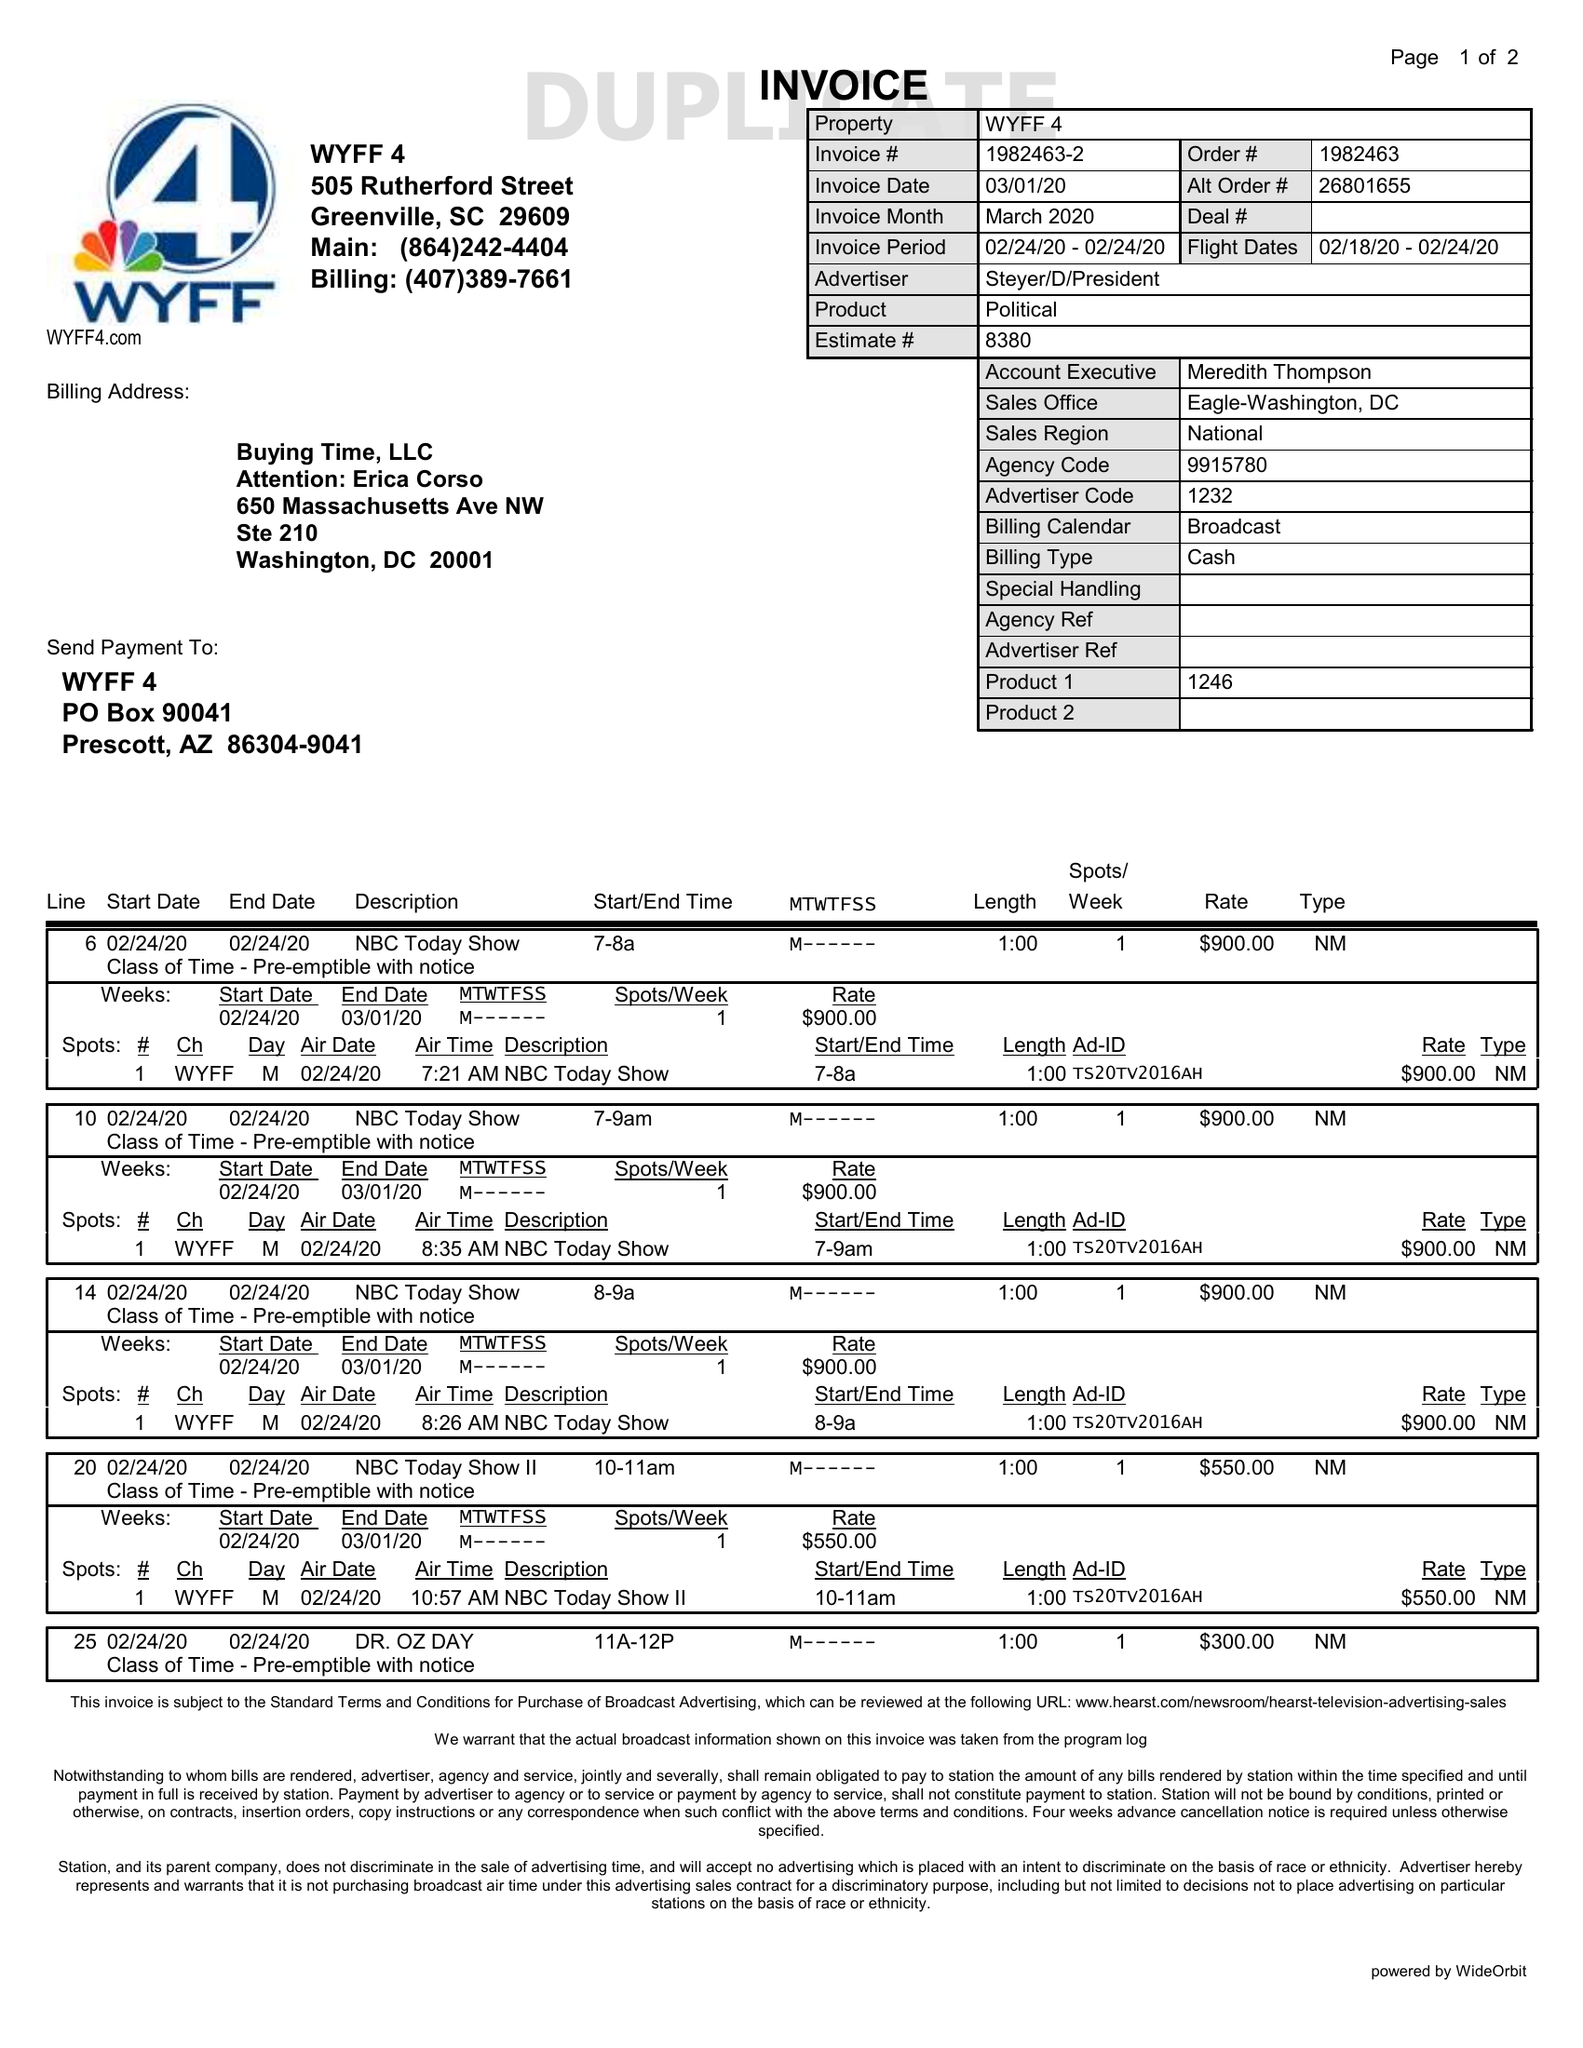What is the value for the contract_num?
Answer the question using a single word or phrase. 1982463 